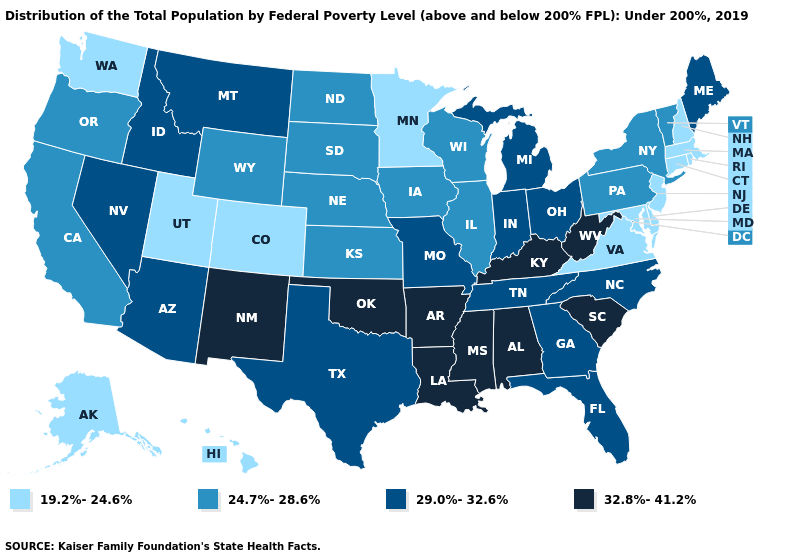What is the lowest value in states that border Minnesota?
Write a very short answer. 24.7%-28.6%. Name the states that have a value in the range 29.0%-32.6%?
Keep it brief. Arizona, Florida, Georgia, Idaho, Indiana, Maine, Michigan, Missouri, Montana, Nevada, North Carolina, Ohio, Tennessee, Texas. What is the value of Alabama?
Quick response, please. 32.8%-41.2%. Name the states that have a value in the range 19.2%-24.6%?
Concise answer only. Alaska, Colorado, Connecticut, Delaware, Hawaii, Maryland, Massachusetts, Minnesota, New Hampshire, New Jersey, Rhode Island, Utah, Virginia, Washington. What is the value of South Dakota?
Keep it brief. 24.7%-28.6%. Does Maine have the lowest value in the Northeast?
Write a very short answer. No. Name the states that have a value in the range 29.0%-32.6%?
Be succinct. Arizona, Florida, Georgia, Idaho, Indiana, Maine, Michigan, Missouri, Montana, Nevada, North Carolina, Ohio, Tennessee, Texas. What is the value of Arizona?
Keep it brief. 29.0%-32.6%. Name the states that have a value in the range 29.0%-32.6%?
Quick response, please. Arizona, Florida, Georgia, Idaho, Indiana, Maine, Michigan, Missouri, Montana, Nevada, North Carolina, Ohio, Tennessee, Texas. What is the lowest value in the West?
Be succinct. 19.2%-24.6%. What is the lowest value in the USA?
Answer briefly. 19.2%-24.6%. Name the states that have a value in the range 24.7%-28.6%?
Be succinct. California, Illinois, Iowa, Kansas, Nebraska, New York, North Dakota, Oregon, Pennsylvania, South Dakota, Vermont, Wisconsin, Wyoming. What is the value of Colorado?
Short answer required. 19.2%-24.6%. Does Iowa have the highest value in the MidWest?
Answer briefly. No. Name the states that have a value in the range 29.0%-32.6%?
Concise answer only. Arizona, Florida, Georgia, Idaho, Indiana, Maine, Michigan, Missouri, Montana, Nevada, North Carolina, Ohio, Tennessee, Texas. 